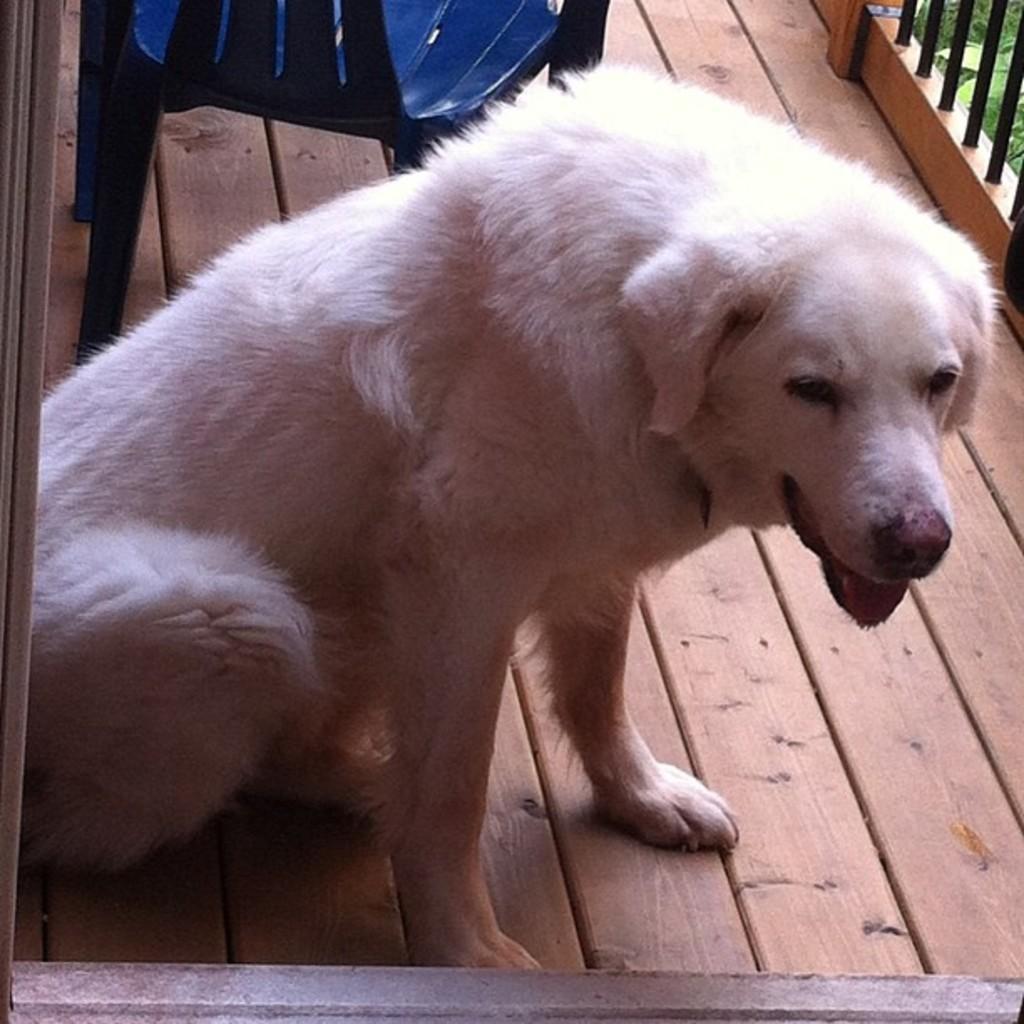Please provide a concise description of this image. In this image there is a dog sitting in the balcony of a building, beside the dog there is a chair. At the top right side of the image there is a railing and we can see the leaves of a tree. 